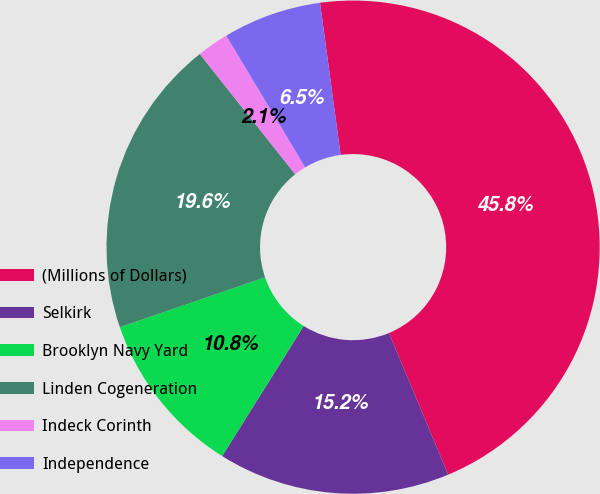Convert chart. <chart><loc_0><loc_0><loc_500><loc_500><pie_chart><fcel>(Millions of Dollars)<fcel>Selkirk<fcel>Brooklyn Navy Yard<fcel>Linden Cogeneration<fcel>Indeck Corinth<fcel>Independence<nl><fcel>45.84%<fcel>15.21%<fcel>10.83%<fcel>19.58%<fcel>2.08%<fcel>6.46%<nl></chart> 